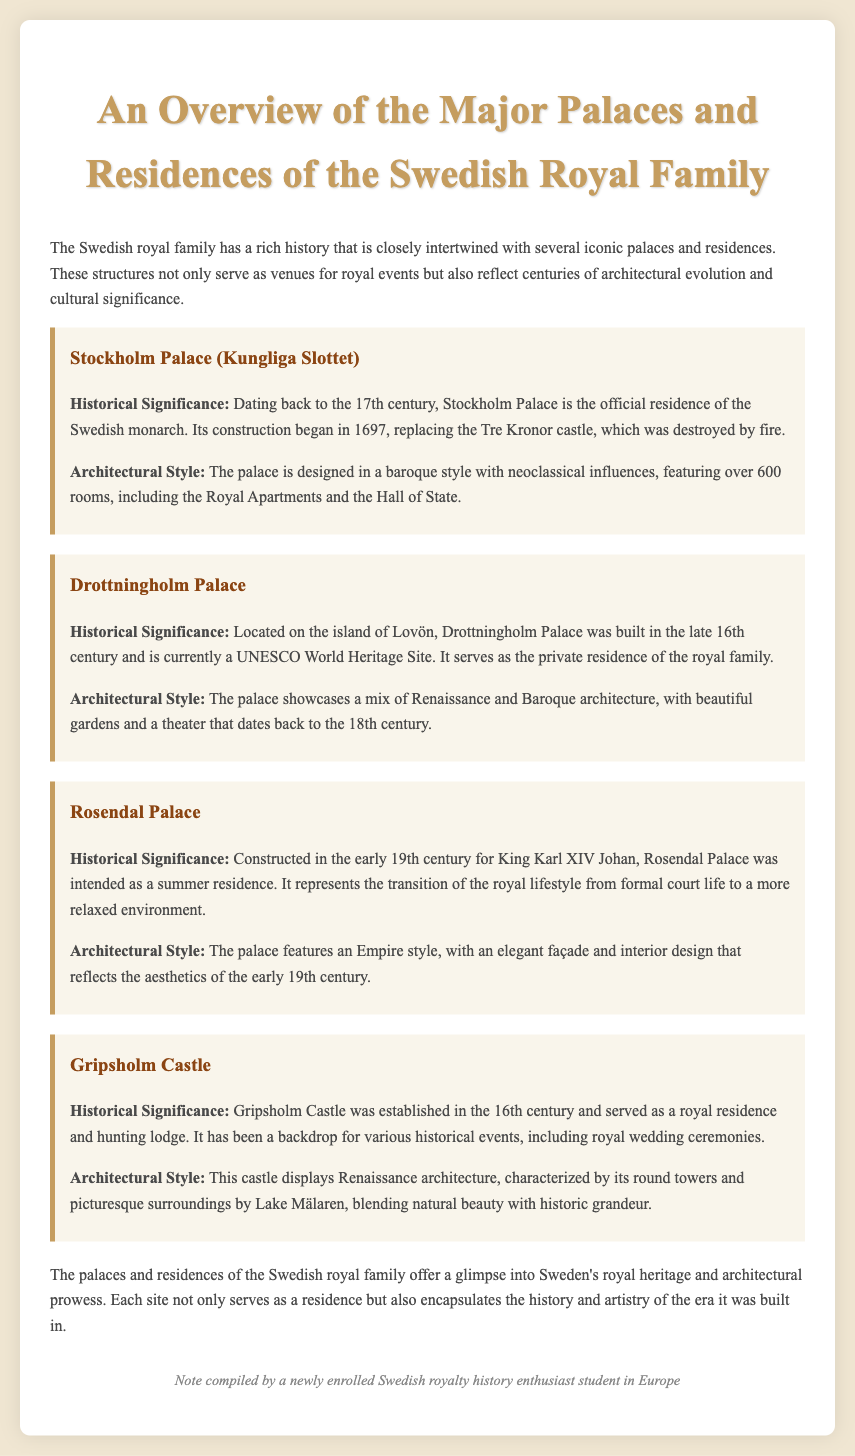What century was Stockholm Palace constructed? The document states that Stockholm Palace dates back to the 17th century.
Answer: 17th century What architectural style is Drottningholm Palace known for? The document mentions that Drottningholm Palace showcases a mix of Renaissance and Baroque architecture.
Answer: Renaissance and Baroque Who built Rosendal Palace? According to the document, Rosendal Palace was constructed for King Karl XIV Johan.
Answer: King Karl XIV Johan How many rooms does Stockholm Palace have? The document specifies that Stockholm Palace features over 600 rooms.
Answer: Over 600 rooms What type of structure is Gripsholm Castle? The document describes Gripsholm Castle as a castle established in the 16th century.
Answer: Castle What does Drottningholm Palace serve as today? The document states that Drottningholm Palace serves as the private residence of the royal family.
Answer: Private residence What reflects the architectural evolution of Swedish royal residences? The document indicates that the palaces and residences reflect centuries of architectural evolution and cultural significance.
Answer: Architecture evolution and cultural significance What is the significance of Gripsholm Castle's location? The document refers to Gripsholm Castle being set by Lake Mälaren, blending natural beauty with historic grandeur.
Answer: By Lake Mälaren What unique aspect of Rosendal Palace is mentioned in its historical significance? The document notes that Rosendal Palace represents the transition of the royal lifestyle from formal court life to a relaxed environment.
Answer: Transition to a relaxed environment 